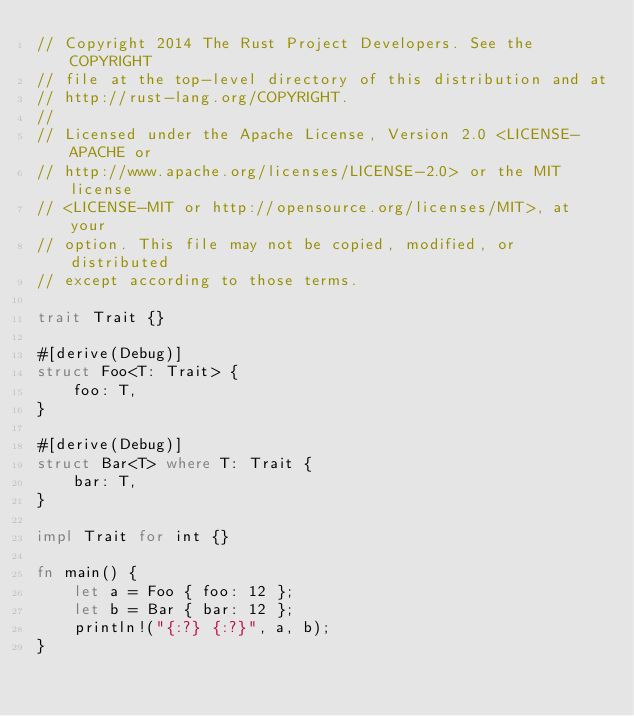<code> <loc_0><loc_0><loc_500><loc_500><_Rust_>// Copyright 2014 The Rust Project Developers. See the COPYRIGHT
// file at the top-level directory of this distribution and at
// http://rust-lang.org/COPYRIGHT.
//
// Licensed under the Apache License, Version 2.0 <LICENSE-APACHE or
// http://www.apache.org/licenses/LICENSE-2.0> or the MIT license
// <LICENSE-MIT or http://opensource.org/licenses/MIT>, at your
// option. This file may not be copied, modified, or distributed
// except according to those terms.

trait Trait {}

#[derive(Debug)]
struct Foo<T: Trait> {
    foo: T,
}

#[derive(Debug)]
struct Bar<T> where T: Trait {
    bar: T,
}

impl Trait for int {}

fn main() {
    let a = Foo { foo: 12 };
    let b = Bar { bar: 12 };
    println!("{:?} {:?}", a, b);
}
</code> 